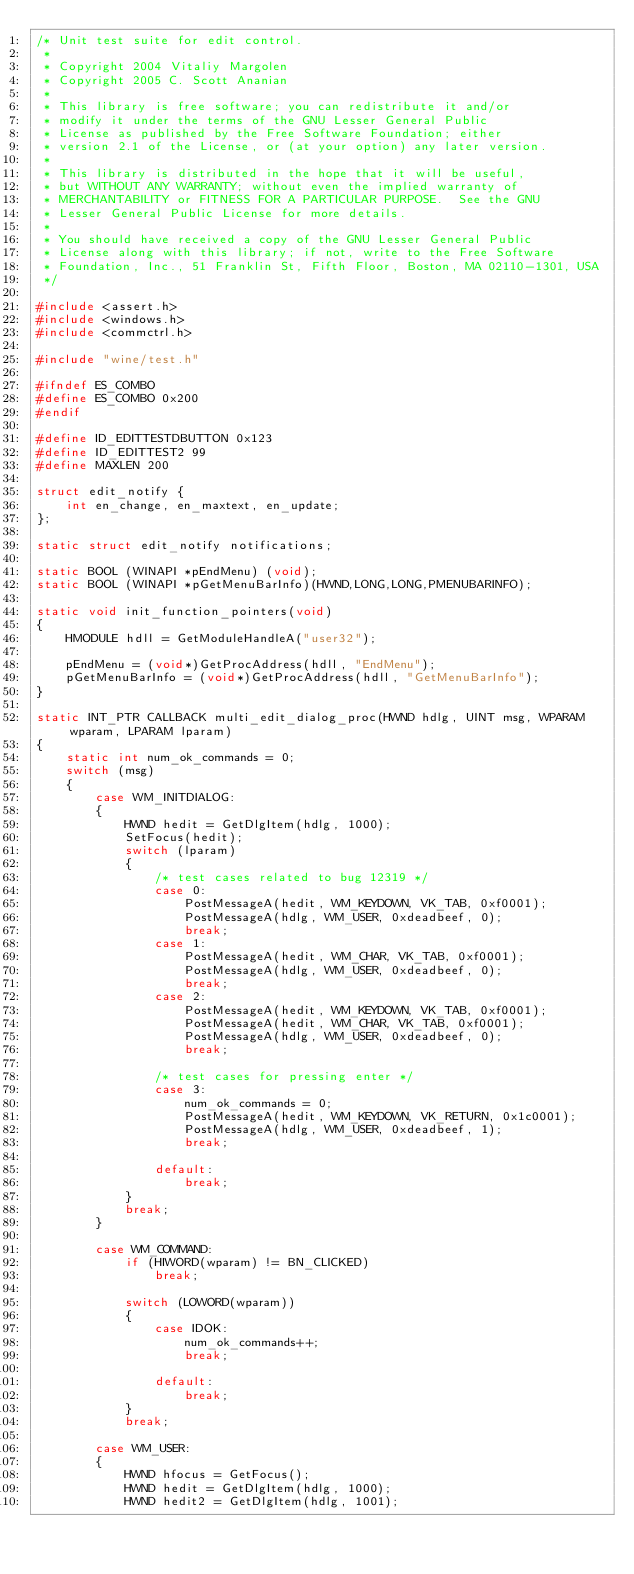Convert code to text. <code><loc_0><loc_0><loc_500><loc_500><_C_>/* Unit test suite for edit control.
 *
 * Copyright 2004 Vitaliy Margolen
 * Copyright 2005 C. Scott Ananian
 *
 * This library is free software; you can redistribute it and/or
 * modify it under the terms of the GNU Lesser General Public
 * License as published by the Free Software Foundation; either
 * version 2.1 of the License, or (at your option) any later version.
 *
 * This library is distributed in the hope that it will be useful,
 * but WITHOUT ANY WARRANTY; without even the implied warranty of
 * MERCHANTABILITY or FITNESS FOR A PARTICULAR PURPOSE.  See the GNU
 * Lesser General Public License for more details.
 *
 * You should have received a copy of the GNU Lesser General Public
 * License along with this library; if not, write to the Free Software
 * Foundation, Inc., 51 Franklin St, Fifth Floor, Boston, MA 02110-1301, USA
 */

#include <assert.h>
#include <windows.h>
#include <commctrl.h>

#include "wine/test.h"

#ifndef ES_COMBO
#define ES_COMBO 0x200
#endif

#define ID_EDITTESTDBUTTON 0x123
#define ID_EDITTEST2 99
#define MAXLEN 200

struct edit_notify {
    int en_change, en_maxtext, en_update;
};

static struct edit_notify notifications;

static BOOL (WINAPI *pEndMenu) (void);
static BOOL (WINAPI *pGetMenuBarInfo)(HWND,LONG,LONG,PMENUBARINFO);

static void init_function_pointers(void)
{
    HMODULE hdll = GetModuleHandleA("user32");

    pEndMenu = (void*)GetProcAddress(hdll, "EndMenu");
    pGetMenuBarInfo = (void*)GetProcAddress(hdll, "GetMenuBarInfo");
}

static INT_PTR CALLBACK multi_edit_dialog_proc(HWND hdlg, UINT msg, WPARAM wparam, LPARAM lparam)
{
    static int num_ok_commands = 0;
    switch (msg)
    {
        case WM_INITDIALOG:
        {
            HWND hedit = GetDlgItem(hdlg, 1000);
            SetFocus(hedit);
            switch (lparam)
            {
                /* test cases related to bug 12319 */
                case 0:
                    PostMessageA(hedit, WM_KEYDOWN, VK_TAB, 0xf0001);
                    PostMessageA(hdlg, WM_USER, 0xdeadbeef, 0);
                    break;
                case 1:
                    PostMessageA(hedit, WM_CHAR, VK_TAB, 0xf0001);
                    PostMessageA(hdlg, WM_USER, 0xdeadbeef, 0);
                    break;
                case 2:
                    PostMessageA(hedit, WM_KEYDOWN, VK_TAB, 0xf0001);
                    PostMessageA(hedit, WM_CHAR, VK_TAB, 0xf0001);
                    PostMessageA(hdlg, WM_USER, 0xdeadbeef, 0);
                    break;

                /* test cases for pressing enter */
                case 3:
                    num_ok_commands = 0;
                    PostMessageA(hedit, WM_KEYDOWN, VK_RETURN, 0x1c0001);
                    PostMessageA(hdlg, WM_USER, 0xdeadbeef, 1);
                    break;

                default:
                    break;
            }
            break;
        }

        case WM_COMMAND:
            if (HIWORD(wparam) != BN_CLICKED)
                break;

            switch (LOWORD(wparam))
            {
                case IDOK:
                    num_ok_commands++;
                    break;

                default:
                    break;
            }
            break;

        case WM_USER:
        {
            HWND hfocus = GetFocus();
            HWND hedit = GetDlgItem(hdlg, 1000);
            HWND hedit2 = GetDlgItem(hdlg, 1001);</code> 